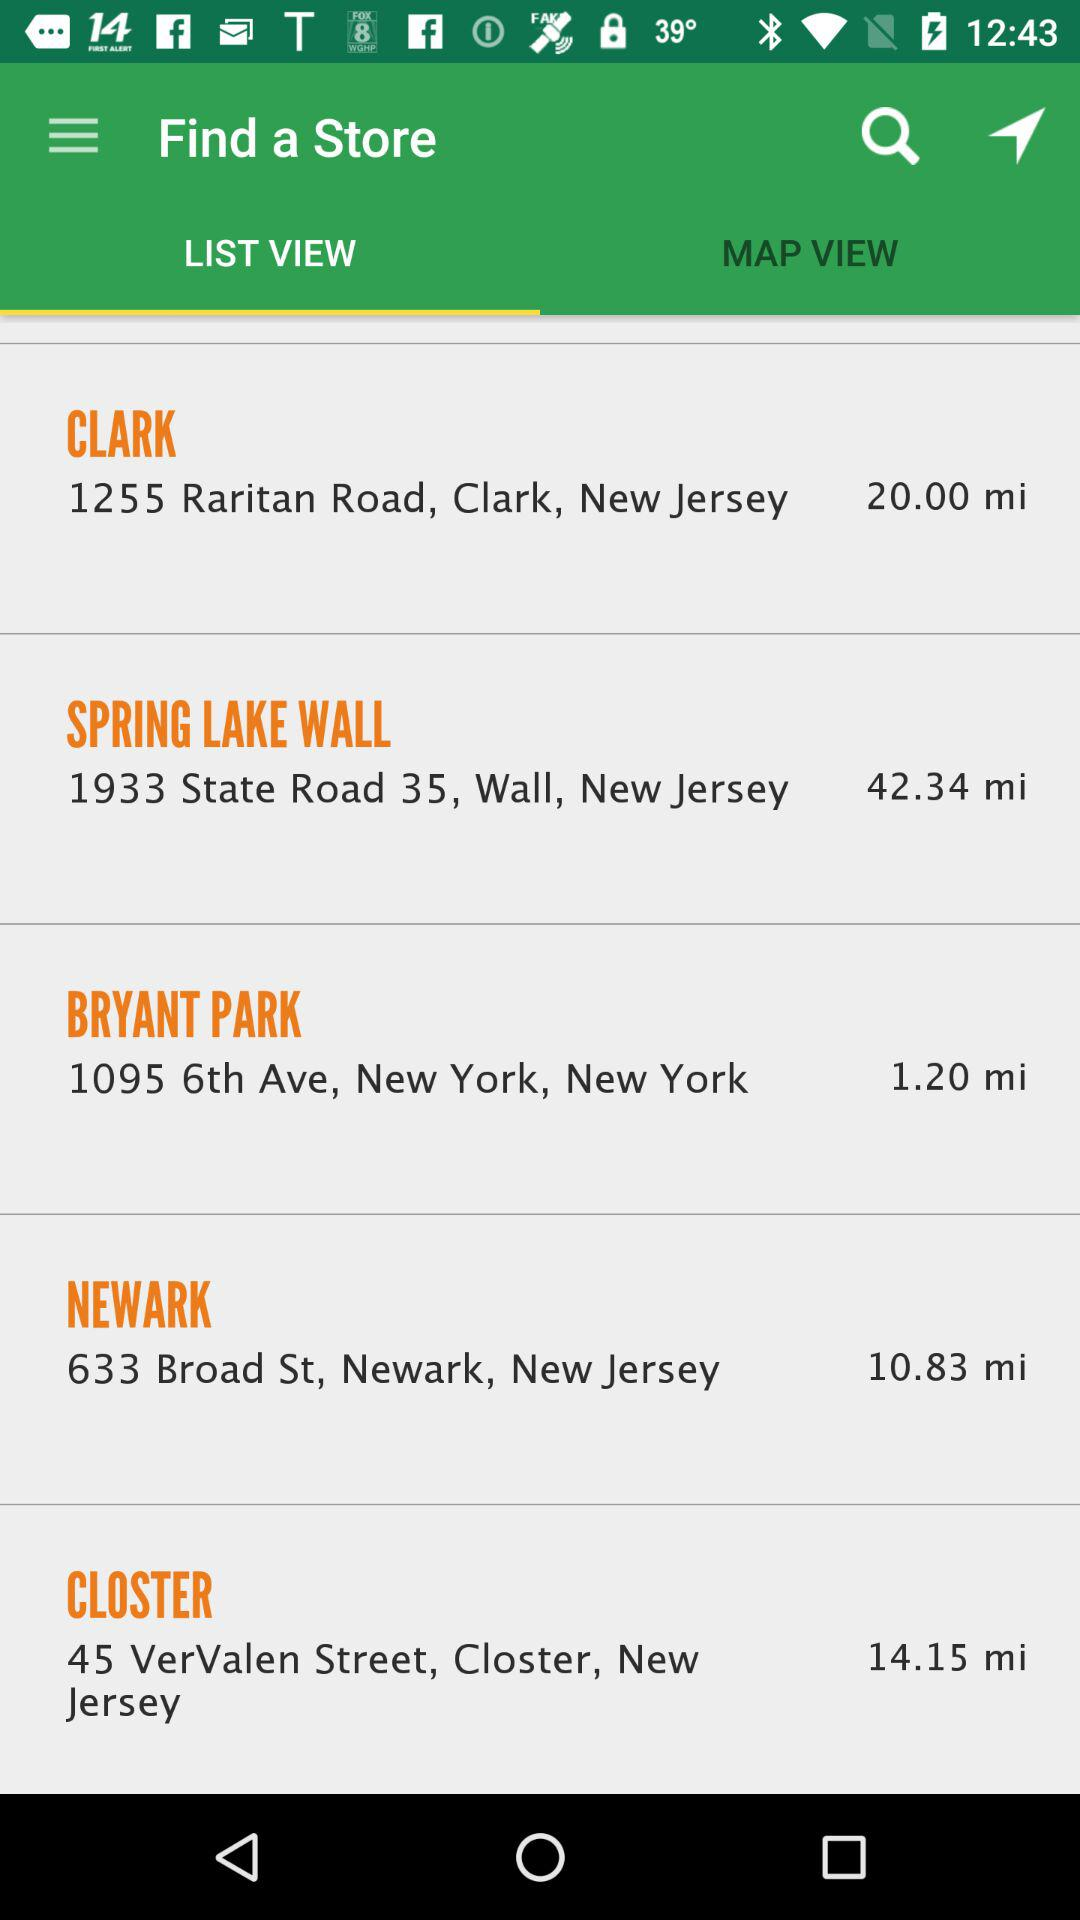Which tab is selected? The selected tab is "LIST VIEW". 